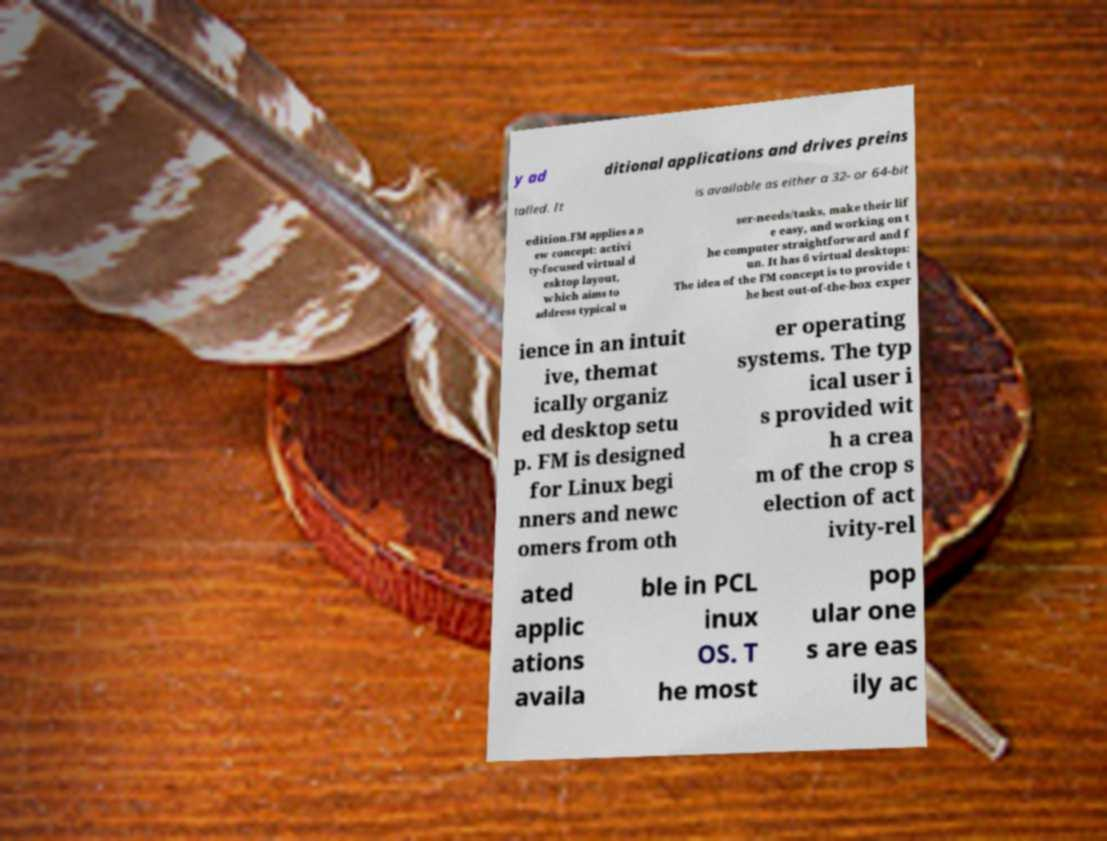I need the written content from this picture converted into text. Can you do that? y ad ditional applications and drives preins talled. It is available as either a 32- or 64-bit edition.FM applies a n ew concept: activi ty-focused virtual d esktop layout, which aims to address typical u ser-needs/tasks, make their lif e easy, and working on t he computer straightforward and f un. It has 6 virtual desktops: The idea of the FM concept is to provide t he best out-of-the-box exper ience in an intuit ive, themat ically organiz ed desktop setu p. FM is designed for Linux begi nners and newc omers from oth er operating systems. The typ ical user i s provided wit h a crea m of the crop s election of act ivity-rel ated applic ations availa ble in PCL inux OS. T he most pop ular one s are eas ily ac 